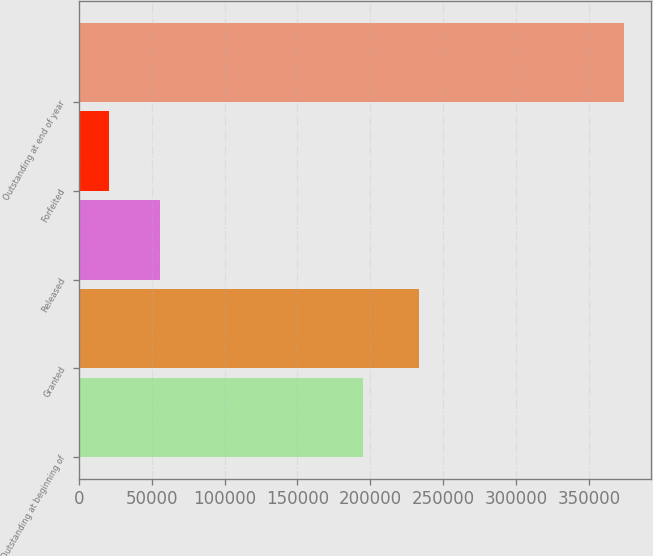<chart> <loc_0><loc_0><loc_500><loc_500><bar_chart><fcel>Outstanding at beginning of<fcel>Granted<fcel>Released<fcel>Forfeited<fcel>Outstanding at end of year<nl><fcel>195159<fcel>233111<fcel>55917.5<fcel>20555<fcel>374180<nl></chart> 